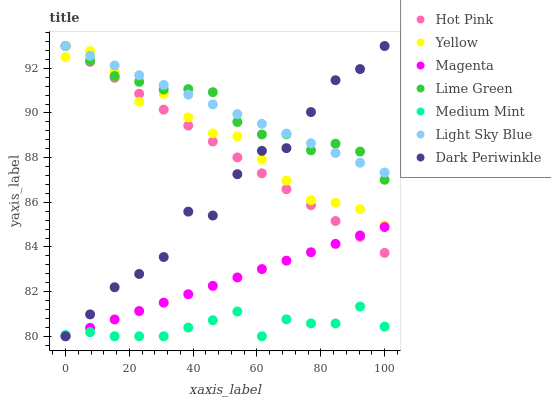Does Medium Mint have the minimum area under the curve?
Answer yes or no. Yes. Does Light Sky Blue have the maximum area under the curve?
Answer yes or no. Yes. Does Hot Pink have the minimum area under the curve?
Answer yes or no. No. Does Hot Pink have the maximum area under the curve?
Answer yes or no. No. Is Magenta the smoothest?
Answer yes or no. Yes. Is Dark Periwinkle the roughest?
Answer yes or no. Yes. Is Hot Pink the smoothest?
Answer yes or no. No. Is Hot Pink the roughest?
Answer yes or no. No. Does Medium Mint have the lowest value?
Answer yes or no. Yes. Does Hot Pink have the lowest value?
Answer yes or no. No. Does Dark Periwinkle have the highest value?
Answer yes or no. Yes. Does Yellow have the highest value?
Answer yes or no. No. Is Medium Mint less than Lime Green?
Answer yes or no. Yes. Is Yellow greater than Magenta?
Answer yes or no. Yes. Does Dark Periwinkle intersect Medium Mint?
Answer yes or no. Yes. Is Dark Periwinkle less than Medium Mint?
Answer yes or no. No. Is Dark Periwinkle greater than Medium Mint?
Answer yes or no. No. Does Medium Mint intersect Lime Green?
Answer yes or no. No. 